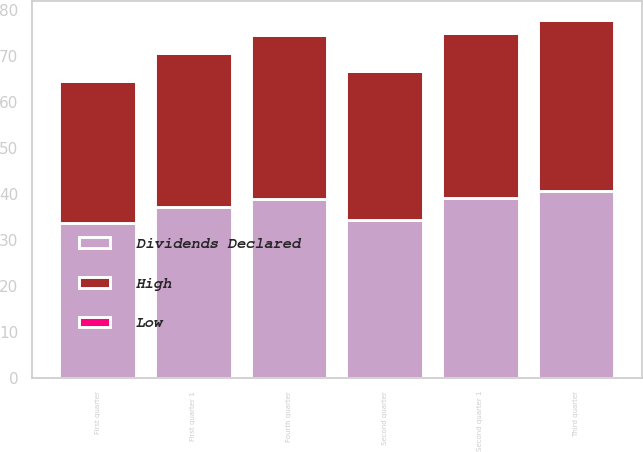<chart> <loc_0><loc_0><loc_500><loc_500><stacked_bar_chart><ecel><fcel>Fourth quarter<fcel>Third quarter<fcel>Second quarter 1<fcel>First quarter 1<fcel>Second quarter<fcel>First quarter<nl><fcel>Dividends Declared<fcel>38.83<fcel>40.66<fcel>39.1<fcel>37.2<fcel>34.39<fcel>33.74<nl><fcel>High<fcel>35.58<fcel>37.11<fcel>35.92<fcel>33.29<fcel>32.22<fcel>30.65<nl><fcel>Low<fcel>0.26<fcel>0.26<fcel>0.26<fcel>0.26<fcel>0.23<fcel>0.23<nl></chart> 